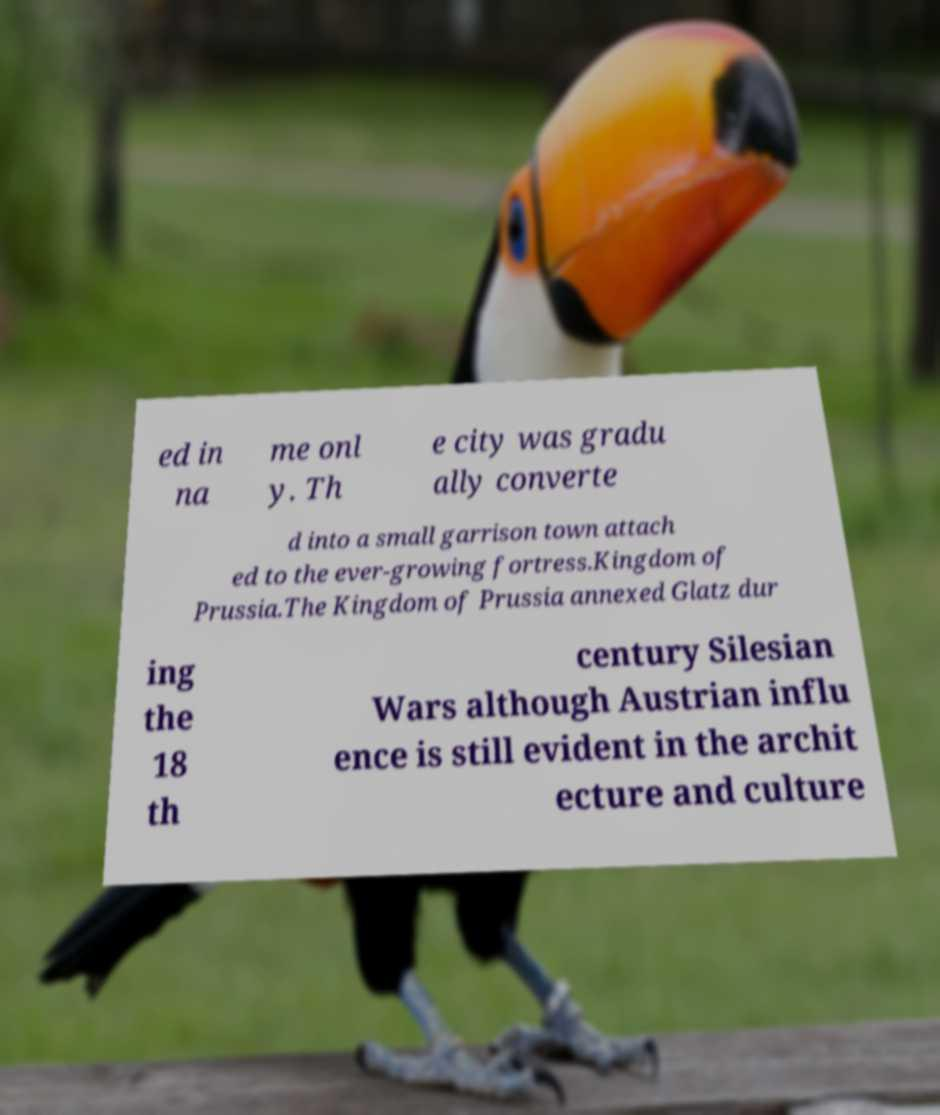Could you assist in decoding the text presented in this image and type it out clearly? ed in na me onl y. Th e city was gradu ally converte d into a small garrison town attach ed to the ever-growing fortress.Kingdom of Prussia.The Kingdom of Prussia annexed Glatz dur ing the 18 th century Silesian Wars although Austrian influ ence is still evident in the archit ecture and culture 